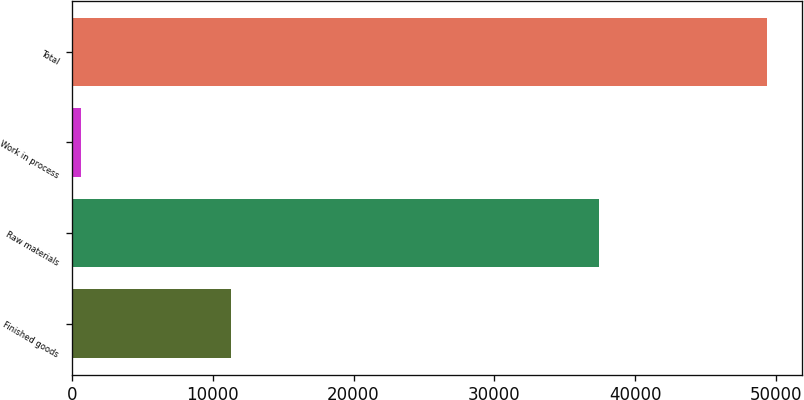Convert chart. <chart><loc_0><loc_0><loc_500><loc_500><bar_chart><fcel>Finished goods<fcel>Raw materials<fcel>Work in process<fcel>Total<nl><fcel>11300<fcel>37387<fcel>645<fcel>49332<nl></chart> 